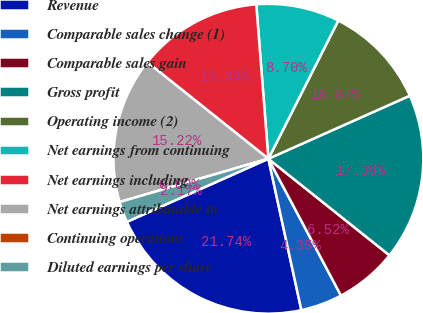Convert chart to OTSL. <chart><loc_0><loc_0><loc_500><loc_500><pie_chart><fcel>Revenue<fcel>Comparable sales change (1)<fcel>Comparable sales gain<fcel>Gross profit<fcel>Operating income (2)<fcel>Net earnings from continuing<fcel>Net earnings including<fcel>Net earnings attributable to<fcel>Continuing operations<fcel>Diluted earnings per share<nl><fcel>21.74%<fcel>4.35%<fcel>6.52%<fcel>17.39%<fcel>10.87%<fcel>8.7%<fcel>13.04%<fcel>15.22%<fcel>0.0%<fcel>2.17%<nl></chart> 